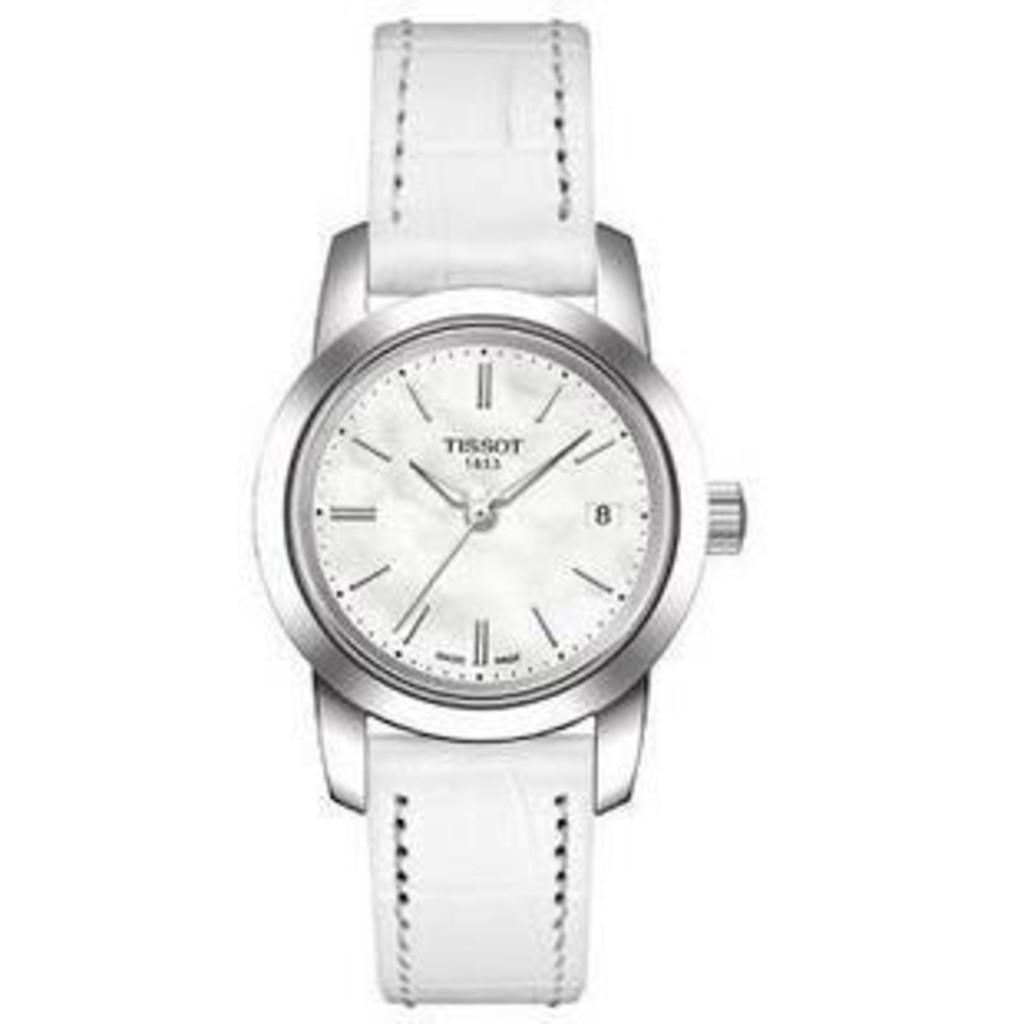<image>
Offer a succinct explanation of the picture presented. A clock with a silver face and a white band that is the brand tissot. 